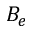<formula> <loc_0><loc_0><loc_500><loc_500>B _ { e }</formula> 